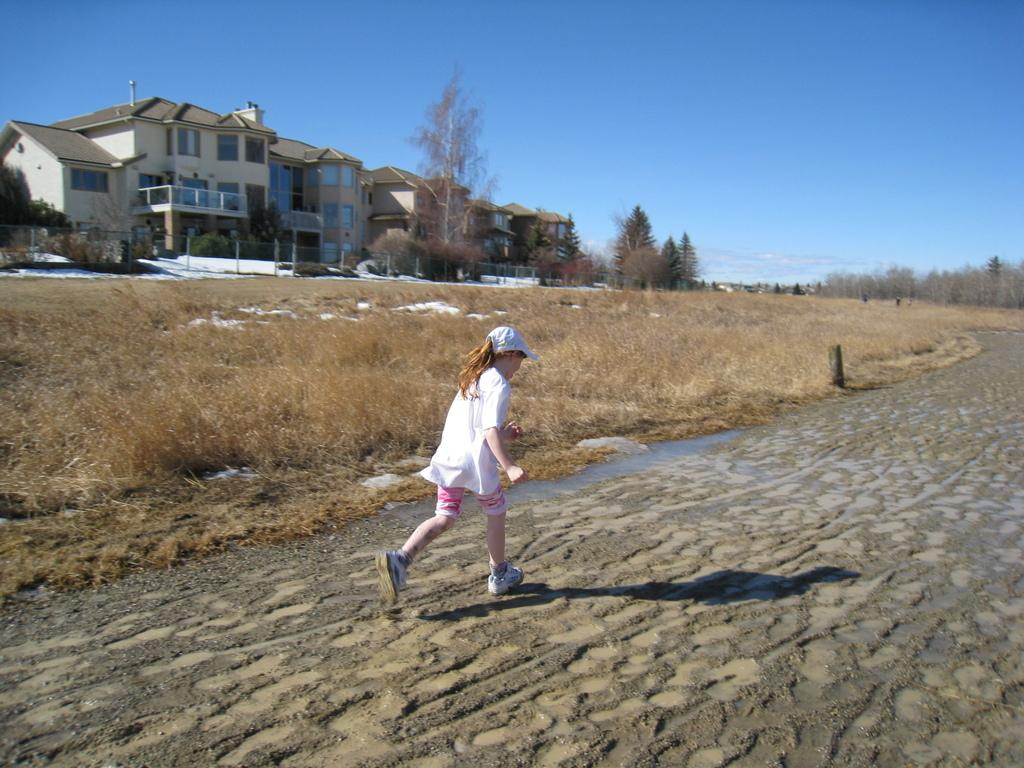What type of structure is visible in the image? There is a house in the image. What is in front of the house? There are trees and grass in front of the house. What is the girl in the image doing? The girl is walking on the road. What can be seen at the top of the image? The sky is visible at the top of the image. What type of support can be seen holding up the house in the image? There is no visible support holding up the house in the image; it appears to be a typical house structure. 